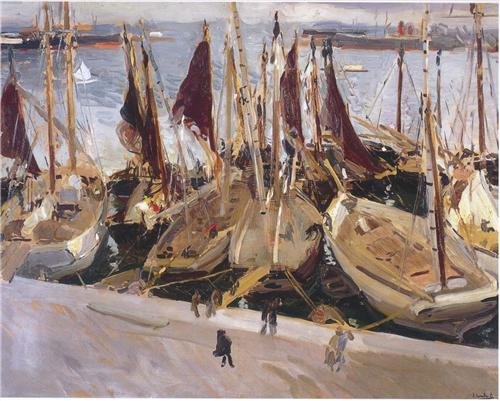If this painting were a scene in a storybook, what would happen next? As the sun rises higher in the sky, the harbor becomes even more animated. Sailors begin to unfurl their sails, preparing to set out for a day of fishing and trading. Children run along the docks, excitedly chasing after wayward seagulls. In the background, the city slowly awakens, with shopkeepers lifting shutters and street vendors setting up their stalls. A mysterious ship, unlike any seen before, glides into the harbor, its sails billowing with a unique insignia, sparking curiosity and whispers among the townsfolk. This marks the beginning of an unexpected adventure, as the ship's crew brings news of distant lands and lost treasures, igniting the imaginations and ambitions of the little harbor town’s residents. 